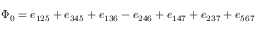<formula> <loc_0><loc_0><loc_500><loc_500>\Phi _ { 0 } = e _ { 1 2 5 } + e _ { 3 4 5 } + e _ { 1 3 6 } - e _ { 2 4 6 } + e _ { 1 4 7 } + e _ { 2 3 7 } + e _ { 5 6 7 }</formula> 